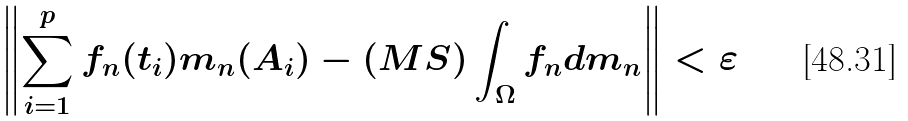Convert formula to latex. <formula><loc_0><loc_0><loc_500><loc_500>\left \| \sum _ { i = 1 } ^ { p } f _ { n } ( t _ { i } ) m _ { n } ( A _ { i } ) - ( M S ) \int _ { \Omega } f _ { n } d m _ { n } \right \| < \varepsilon \,</formula> 